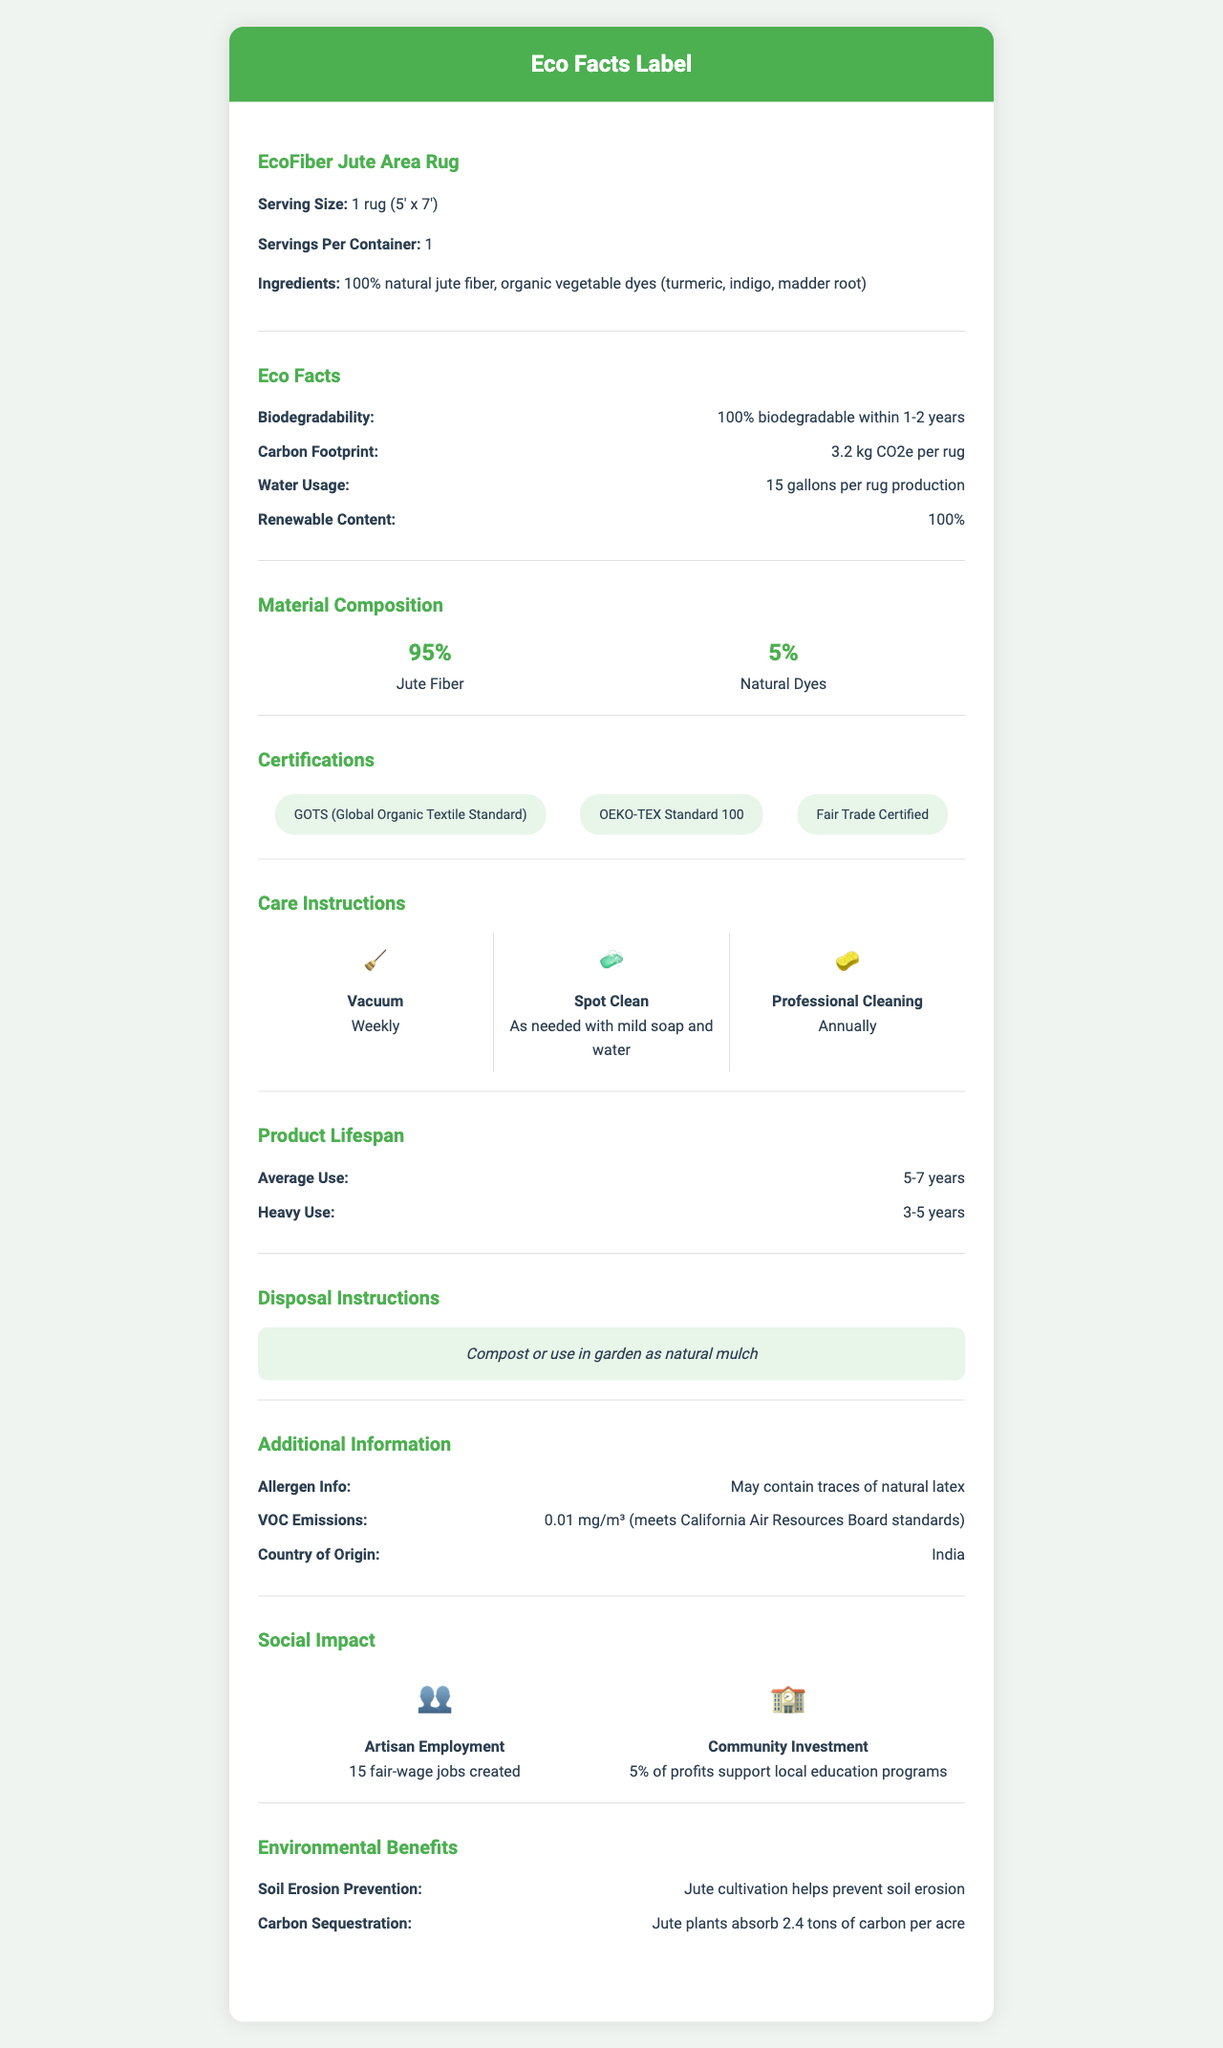what is the serving size for the EcoFiber Jute Area Rug? The document explicitly states that the serving size for the EcoFiber Jute Area Rug is "1 rug (5' x 7')".
Answer: 1 rug (5' x 7') which ingredients are mentioned in the EcoFiber Jute Area Rug? The document lists the ingredients as "100% natural jute fiber, organic vegetable dyes (turmeric, indigo, madder root)".
Answer: 100% natural jute fiber, organic vegetable dyes (turmeric, indigo, madder root) how often should you vacuum the jute area rug? The care instructions section specifies that the rug should be vacuumed weekly.
Answer: Weekly what is the carbon footprint for the production of one rug? The "Eco Facts" section includes the carbon footprint as "3.2 kg CO2e per rug".
Answer: 3.2 kg CO2e per rug list two certifications for the EcoFiber Jute Area Rug. The document includes multiple certifications, including "GOTS (Global Organic Textile Standard)" and "OEKO-TEX Standard 100".
Answer: GOTS (Global Organic Textile Standard), OEKO-TEX Standard 100 what is the average product lifespan under heavy use? The section on product lifespan indicates that under heavy use, the average lifespan is "3-5 years".
Answer: 3-5 years which country is the EcoFiber Jute Area Rug manufactured in? A. China B. India C. Bangladesh The section indicating the country of origin states that the rugs are made in India.
Answer: B. India how much water is used in the production of one rug? A. 5 gallons B. 15 gallons C. 25 gallons D. 35 gallons The "Eco Facts" section states that the water usage is "15 gallons per rug production".
Answer: B. 15 gallons is the EcoFiber Jute Area Rug 100% biodegradable? The "Eco Facts" section confirms that the rug is "100% biodegradable within 1-2 years".
Answer: Yes describe the main idea of this document. This document informs readers about the sustainable and organic aspects of the rug, including its composition, care, impact on the environment, and benefits to the community.
Answer: The document provides detailed information on the eco-friendliness, ingredients, care instructions, lifespan, certifications, and social and environmental impacts of the EcoFiber Jute Area Rug. how much carbon do jute plants absorb per acre? The "Environmental Benefits" section lists this specific data point, stating "Jute plants absorb 2.4 tons of carbon per acre."
Answer: 2.4 tons of carbon per acre what certification ensures fair wages for artisans? The document includes "Fair Trade Certified" in the list of certifications, which ensures fair wages for workers.
Answer: Fair Trade Certified what's the recommended professional cleaning frequency? The care instructions specify that professional cleaning should be done annually.
Answer: Annually how can you dispose of the jute area rug? The disposal instructions suggest composting or using the rug as natural mulch for disposal.
Answer: Compost or use in garden as natural mulch is the rug made from renewable materials? The "Eco Facts" section indicates that the rug is made from "100% renewable content."
Answer: Yes how many artisans are employed for creating these rugs? The "Social Impact" section specifies that 15 fair-wage jobs are created.
Answer: 15 fair-wage jobs created what is the VOC emission level of the rug? The section on additional information notes the VOC emission level as "0.01 mg/m³".
Answer: 0.01 mg/m³ what allergens might the rug contain? The allergen information section states that the rug may contain traces of natural latex.
Answer: May contain traces of natural latex how does jute cultivation benefit the environment? The "Environmental Benefits" section mentions that jute cultivation helps prevent soil erosion.
Answer: Jute cultivation helps prevent soil erosion what percentage of the rug is made from natural dyes? The material composition section indicates that natural dyes make up 5% of the rug's material.
Answer: 5% what are the colors derived from? The ingredients section lists the sources of natural dyes as turmeric, indigo, and madder root.
Answer: Organic vegetable dyes (turmeric, indigo, madder root) does the document provide details on the cost of the rug? The document does not mention the cost or any pricing information for the rug.
Answer: Not enough information 